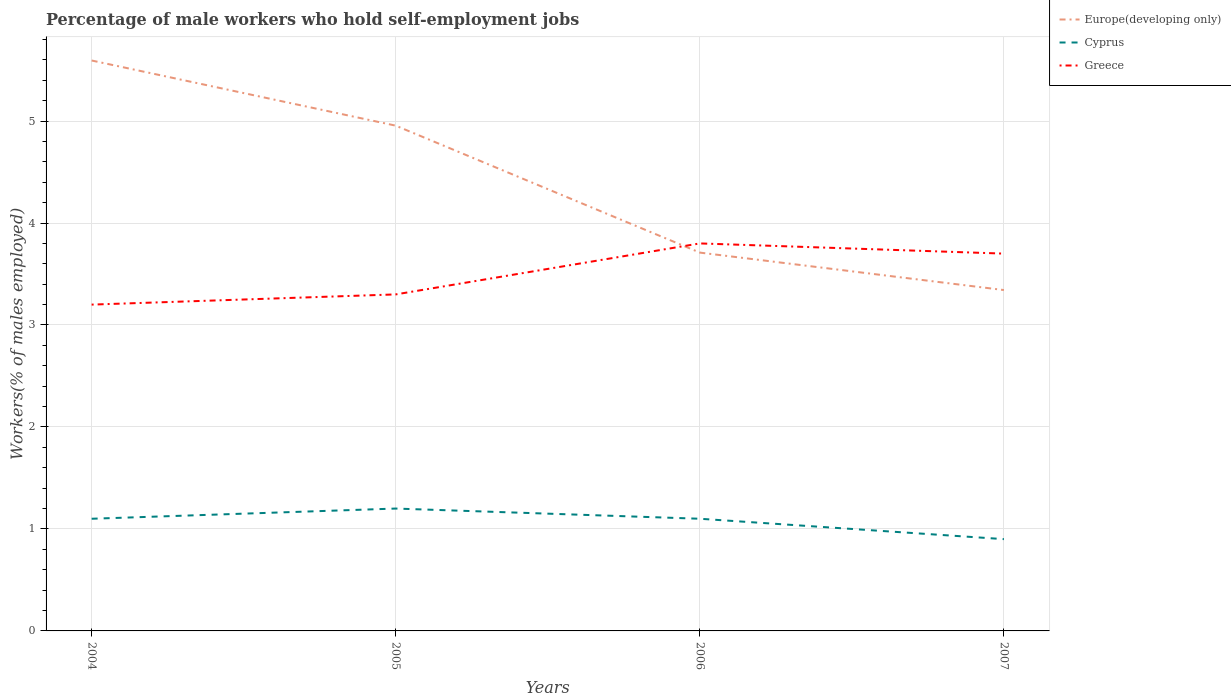Does the line corresponding to Europe(developing only) intersect with the line corresponding to Greece?
Your answer should be compact. Yes. Across all years, what is the maximum percentage of self-employed male workers in Cyprus?
Provide a succinct answer. 0.9. In which year was the percentage of self-employed male workers in Cyprus maximum?
Ensure brevity in your answer.  2007. What is the total percentage of self-employed male workers in Cyprus in the graph?
Provide a short and direct response. 0.3. What is the difference between the highest and the second highest percentage of self-employed male workers in Cyprus?
Keep it short and to the point. 0.3. How many lines are there?
Offer a terse response. 3. Are the values on the major ticks of Y-axis written in scientific E-notation?
Keep it short and to the point. No. Where does the legend appear in the graph?
Your answer should be compact. Top right. How many legend labels are there?
Your response must be concise. 3. How are the legend labels stacked?
Ensure brevity in your answer.  Vertical. What is the title of the graph?
Offer a terse response. Percentage of male workers who hold self-employment jobs. Does "West Bank and Gaza" appear as one of the legend labels in the graph?
Keep it short and to the point. No. What is the label or title of the Y-axis?
Your response must be concise. Workers(% of males employed). What is the Workers(% of males employed) of Europe(developing only) in 2004?
Provide a short and direct response. 5.59. What is the Workers(% of males employed) of Cyprus in 2004?
Your response must be concise. 1.1. What is the Workers(% of males employed) in Greece in 2004?
Give a very brief answer. 3.2. What is the Workers(% of males employed) in Europe(developing only) in 2005?
Your answer should be very brief. 4.95. What is the Workers(% of males employed) in Cyprus in 2005?
Offer a very short reply. 1.2. What is the Workers(% of males employed) in Greece in 2005?
Ensure brevity in your answer.  3.3. What is the Workers(% of males employed) in Europe(developing only) in 2006?
Offer a very short reply. 3.71. What is the Workers(% of males employed) in Cyprus in 2006?
Your answer should be compact. 1.1. What is the Workers(% of males employed) in Greece in 2006?
Your response must be concise. 3.8. What is the Workers(% of males employed) in Europe(developing only) in 2007?
Make the answer very short. 3.34. What is the Workers(% of males employed) of Cyprus in 2007?
Offer a very short reply. 0.9. What is the Workers(% of males employed) of Greece in 2007?
Offer a terse response. 3.7. Across all years, what is the maximum Workers(% of males employed) in Europe(developing only)?
Your answer should be compact. 5.59. Across all years, what is the maximum Workers(% of males employed) of Cyprus?
Make the answer very short. 1.2. Across all years, what is the maximum Workers(% of males employed) of Greece?
Keep it short and to the point. 3.8. Across all years, what is the minimum Workers(% of males employed) in Europe(developing only)?
Make the answer very short. 3.34. Across all years, what is the minimum Workers(% of males employed) in Cyprus?
Make the answer very short. 0.9. Across all years, what is the minimum Workers(% of males employed) in Greece?
Give a very brief answer. 3.2. What is the total Workers(% of males employed) in Europe(developing only) in the graph?
Offer a very short reply. 17.6. What is the total Workers(% of males employed) of Greece in the graph?
Offer a terse response. 14. What is the difference between the Workers(% of males employed) of Europe(developing only) in 2004 and that in 2005?
Your answer should be very brief. 0.64. What is the difference between the Workers(% of males employed) of Cyprus in 2004 and that in 2005?
Provide a short and direct response. -0.1. What is the difference between the Workers(% of males employed) of Greece in 2004 and that in 2005?
Ensure brevity in your answer.  -0.1. What is the difference between the Workers(% of males employed) in Europe(developing only) in 2004 and that in 2006?
Make the answer very short. 1.88. What is the difference between the Workers(% of males employed) in Greece in 2004 and that in 2006?
Keep it short and to the point. -0.6. What is the difference between the Workers(% of males employed) of Europe(developing only) in 2004 and that in 2007?
Your answer should be very brief. 2.25. What is the difference between the Workers(% of males employed) in Cyprus in 2004 and that in 2007?
Offer a very short reply. 0.2. What is the difference between the Workers(% of males employed) of Greece in 2004 and that in 2007?
Provide a succinct answer. -0.5. What is the difference between the Workers(% of males employed) in Europe(developing only) in 2005 and that in 2006?
Offer a very short reply. 1.24. What is the difference between the Workers(% of males employed) in Europe(developing only) in 2005 and that in 2007?
Provide a short and direct response. 1.61. What is the difference between the Workers(% of males employed) of Cyprus in 2005 and that in 2007?
Give a very brief answer. 0.3. What is the difference between the Workers(% of males employed) of Europe(developing only) in 2006 and that in 2007?
Ensure brevity in your answer.  0.37. What is the difference between the Workers(% of males employed) of Cyprus in 2006 and that in 2007?
Ensure brevity in your answer.  0.2. What is the difference between the Workers(% of males employed) in Greece in 2006 and that in 2007?
Provide a succinct answer. 0.1. What is the difference between the Workers(% of males employed) of Europe(developing only) in 2004 and the Workers(% of males employed) of Cyprus in 2005?
Your answer should be very brief. 4.39. What is the difference between the Workers(% of males employed) in Europe(developing only) in 2004 and the Workers(% of males employed) in Greece in 2005?
Your answer should be compact. 2.29. What is the difference between the Workers(% of males employed) of Europe(developing only) in 2004 and the Workers(% of males employed) of Cyprus in 2006?
Keep it short and to the point. 4.49. What is the difference between the Workers(% of males employed) in Europe(developing only) in 2004 and the Workers(% of males employed) in Greece in 2006?
Make the answer very short. 1.79. What is the difference between the Workers(% of males employed) of Europe(developing only) in 2004 and the Workers(% of males employed) of Cyprus in 2007?
Ensure brevity in your answer.  4.69. What is the difference between the Workers(% of males employed) in Europe(developing only) in 2004 and the Workers(% of males employed) in Greece in 2007?
Your answer should be compact. 1.89. What is the difference between the Workers(% of males employed) of Europe(developing only) in 2005 and the Workers(% of males employed) of Cyprus in 2006?
Make the answer very short. 3.85. What is the difference between the Workers(% of males employed) of Europe(developing only) in 2005 and the Workers(% of males employed) of Greece in 2006?
Make the answer very short. 1.15. What is the difference between the Workers(% of males employed) in Cyprus in 2005 and the Workers(% of males employed) in Greece in 2006?
Keep it short and to the point. -2.6. What is the difference between the Workers(% of males employed) in Europe(developing only) in 2005 and the Workers(% of males employed) in Cyprus in 2007?
Your answer should be compact. 4.05. What is the difference between the Workers(% of males employed) of Europe(developing only) in 2005 and the Workers(% of males employed) of Greece in 2007?
Your response must be concise. 1.25. What is the difference between the Workers(% of males employed) in Europe(developing only) in 2006 and the Workers(% of males employed) in Cyprus in 2007?
Offer a very short reply. 2.81. What is the difference between the Workers(% of males employed) in Cyprus in 2006 and the Workers(% of males employed) in Greece in 2007?
Offer a terse response. -2.6. What is the average Workers(% of males employed) of Europe(developing only) per year?
Give a very brief answer. 4.4. What is the average Workers(% of males employed) of Cyprus per year?
Provide a short and direct response. 1.07. What is the average Workers(% of males employed) of Greece per year?
Your answer should be compact. 3.5. In the year 2004, what is the difference between the Workers(% of males employed) of Europe(developing only) and Workers(% of males employed) of Cyprus?
Provide a short and direct response. 4.49. In the year 2004, what is the difference between the Workers(% of males employed) of Europe(developing only) and Workers(% of males employed) of Greece?
Your answer should be very brief. 2.39. In the year 2005, what is the difference between the Workers(% of males employed) in Europe(developing only) and Workers(% of males employed) in Cyprus?
Ensure brevity in your answer.  3.75. In the year 2005, what is the difference between the Workers(% of males employed) of Europe(developing only) and Workers(% of males employed) of Greece?
Keep it short and to the point. 1.65. In the year 2005, what is the difference between the Workers(% of males employed) in Cyprus and Workers(% of males employed) in Greece?
Give a very brief answer. -2.1. In the year 2006, what is the difference between the Workers(% of males employed) in Europe(developing only) and Workers(% of males employed) in Cyprus?
Keep it short and to the point. 2.61. In the year 2006, what is the difference between the Workers(% of males employed) of Europe(developing only) and Workers(% of males employed) of Greece?
Offer a very short reply. -0.09. In the year 2007, what is the difference between the Workers(% of males employed) of Europe(developing only) and Workers(% of males employed) of Cyprus?
Your response must be concise. 2.44. In the year 2007, what is the difference between the Workers(% of males employed) in Europe(developing only) and Workers(% of males employed) in Greece?
Make the answer very short. -0.36. In the year 2007, what is the difference between the Workers(% of males employed) in Cyprus and Workers(% of males employed) in Greece?
Offer a terse response. -2.8. What is the ratio of the Workers(% of males employed) in Europe(developing only) in 2004 to that in 2005?
Your answer should be very brief. 1.13. What is the ratio of the Workers(% of males employed) of Greece in 2004 to that in 2005?
Give a very brief answer. 0.97. What is the ratio of the Workers(% of males employed) in Europe(developing only) in 2004 to that in 2006?
Provide a succinct answer. 1.51. What is the ratio of the Workers(% of males employed) in Greece in 2004 to that in 2006?
Ensure brevity in your answer.  0.84. What is the ratio of the Workers(% of males employed) in Europe(developing only) in 2004 to that in 2007?
Your answer should be very brief. 1.67. What is the ratio of the Workers(% of males employed) of Cyprus in 2004 to that in 2007?
Ensure brevity in your answer.  1.22. What is the ratio of the Workers(% of males employed) in Greece in 2004 to that in 2007?
Offer a very short reply. 0.86. What is the ratio of the Workers(% of males employed) in Europe(developing only) in 2005 to that in 2006?
Your answer should be very brief. 1.34. What is the ratio of the Workers(% of males employed) of Greece in 2005 to that in 2006?
Keep it short and to the point. 0.87. What is the ratio of the Workers(% of males employed) in Europe(developing only) in 2005 to that in 2007?
Make the answer very short. 1.48. What is the ratio of the Workers(% of males employed) of Greece in 2005 to that in 2007?
Offer a terse response. 0.89. What is the ratio of the Workers(% of males employed) of Europe(developing only) in 2006 to that in 2007?
Your answer should be compact. 1.11. What is the ratio of the Workers(% of males employed) of Cyprus in 2006 to that in 2007?
Make the answer very short. 1.22. What is the ratio of the Workers(% of males employed) of Greece in 2006 to that in 2007?
Offer a very short reply. 1.03. What is the difference between the highest and the second highest Workers(% of males employed) of Europe(developing only)?
Offer a very short reply. 0.64. What is the difference between the highest and the second highest Workers(% of males employed) of Cyprus?
Keep it short and to the point. 0.1. What is the difference between the highest and the second highest Workers(% of males employed) of Greece?
Your answer should be very brief. 0.1. What is the difference between the highest and the lowest Workers(% of males employed) in Europe(developing only)?
Make the answer very short. 2.25. 